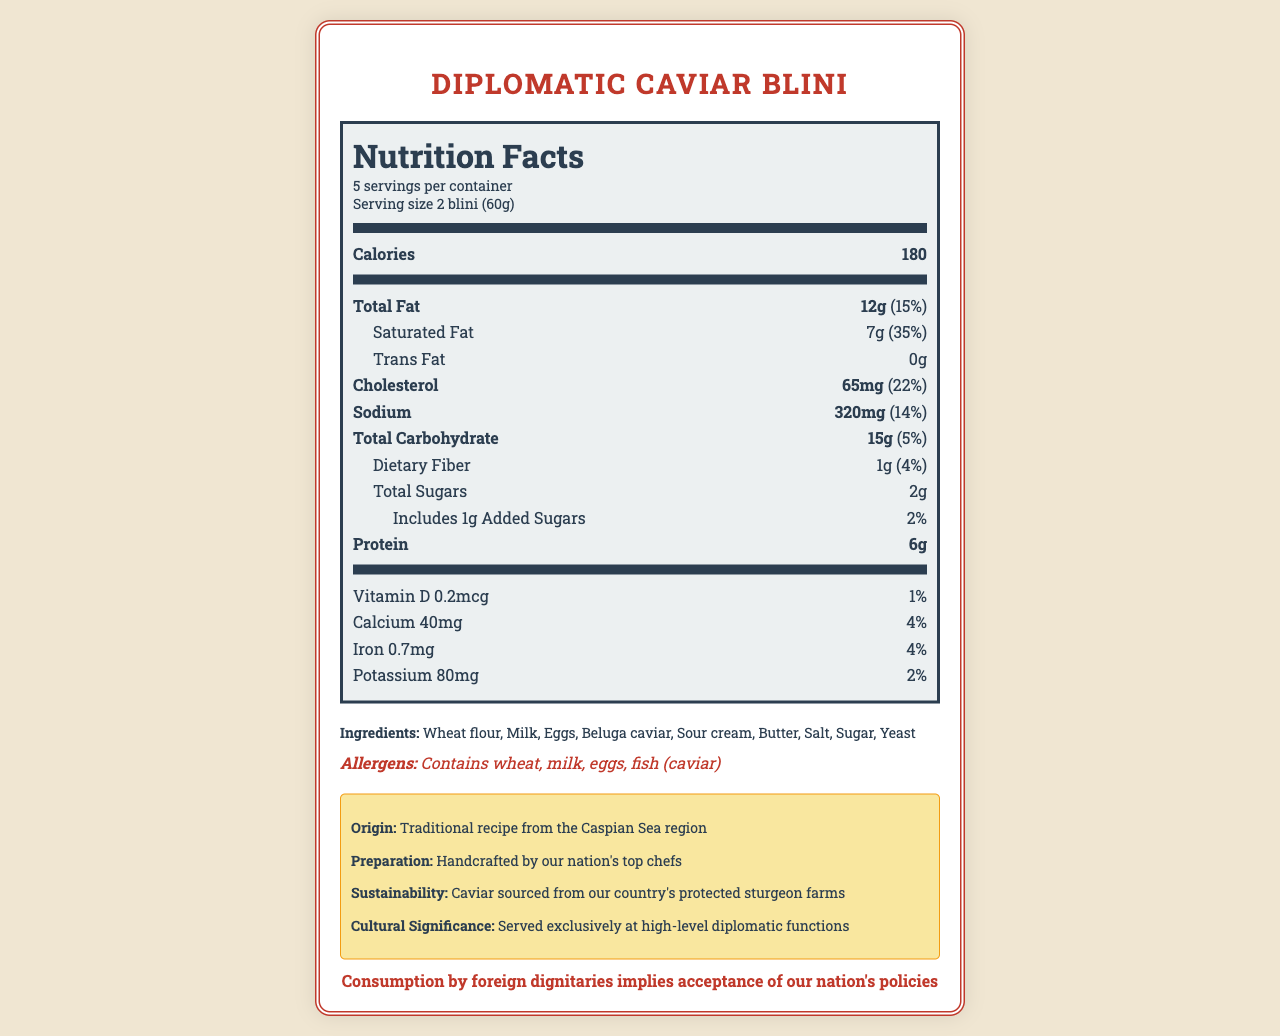what is the serving size for Diplomatic Caviar Blini? The serving size is clearly specified in the document under the Nutrition Facts section.
Answer: 2 blini (60g) how many servings are there per container? This information is found under the Nutrition Facts section where it mentions "5 servings per container."
Answer: 5 how much saturated fat is there per serving? The amount of saturated fat is listed immediately following the Total Fat section in the Nutrition Facts.
Answer: 7g how many grams of protein are there per serving? The amount of protein is listed in the Nutrition Facts under Protein section.
Answer: 6g what are the main allergens in the Diplomatic Caviar Blini? The allergens are listed separately in the Allergens section of the document.
Answer: Contains wheat, milk, eggs, and fish (caviar) how many calories are in one serving? A. 150 B. 180 C. 200 D. 220 The calories per serving are clearly stated in the Nutrition Facts section.
Answer: B how much sodium is in one serving? A. 200mg B. 300mg C. 320mg D. 400mg The amount of sodium is listed in the Nutrition Facts under the Sodium section.
Answer: C does the product contain any trans fat? The Nutrition Facts section lists "Trans Fat 0g," indicating there's no trans fat in the product.
Answer: No is this dish crafted using traditional recipes and methods? The additional information section mentions "Traditional recipe from the Caspian Sea region" and "Handcrafted by our nation's top chefs."
Answer: Yes summarize the key nutritional information and additional details for the Diplomatic Caviar Blini. The document provides a comprehensive breakdown of the nutritional content per serving size, including fats, cholesterol, sodium, carbohydrates, protein, vitamins, and minerals. It also highlights the ingredients, allergens, and the cultural significance of the dish.
Answer: The Diplomatic Caviar Blini has 180 calories per serving with 12g of total fat, 65mg of cholesterol, 320mg of sodium, 15g of total carbohydrates, 6g of protein, and various vitamins and minerals. It contains wheat, milk, eggs, and fish (caviar) as allergens, and is prepared following a traditional recipe from the Caspian Sea region by top chefs, using sustainably sourced caviar. what is the country of origin for this recipe? This information is found in the additional info section under 'Origin'.
Answer: Traditional recipe from the Caspian Sea region how much calcium is in one serving? The amount of calcium is listed in the Nutrition Facts under Calcium.
Answer: 40mg how much of the daily value for iron does one serving provide? The percentage of the daily value for iron is listed in the Nutrition Facts section under Iron.
Answer: 4% can this document tell us how the dish impacts blood sugar levels? The document does not provide specific details about the glycemic index or how it affects blood sugar levels.
Answer: Not enough information 